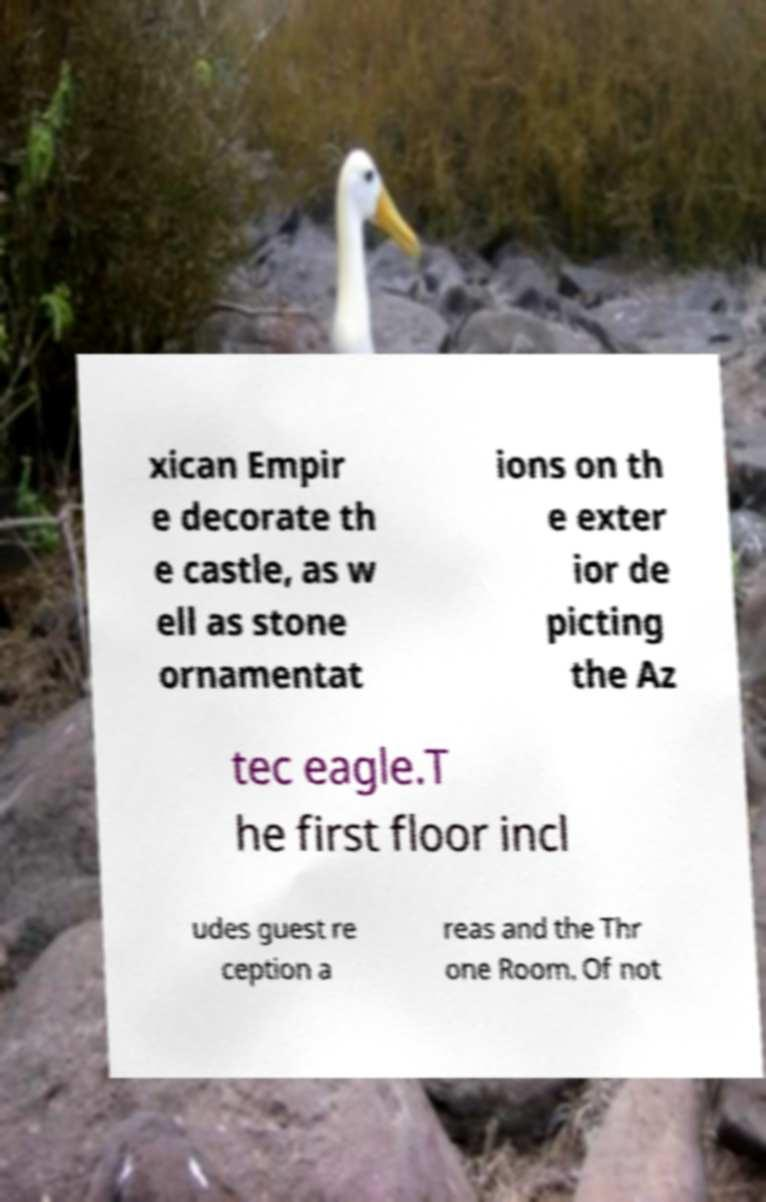Can you accurately transcribe the text from the provided image for me? xican Empir e decorate th e castle, as w ell as stone ornamentat ions on th e exter ior de picting the Az tec eagle.T he first floor incl udes guest re ception a reas and the Thr one Room. Of not 